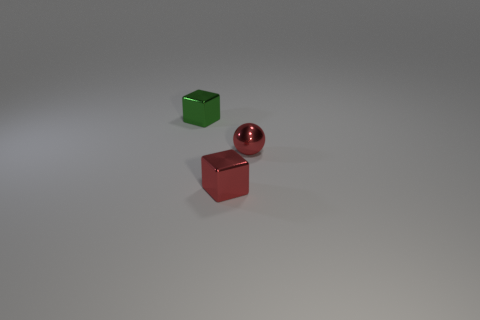Add 2 small red metal objects. How many objects exist? 5 Subtract all cubes. How many objects are left? 1 Add 2 red shiny balls. How many red shiny balls are left? 3 Add 1 blue metal objects. How many blue metal objects exist? 1 Subtract 0 yellow cylinders. How many objects are left? 3 Subtract all small metallic cylinders. Subtract all small metal cubes. How many objects are left? 1 